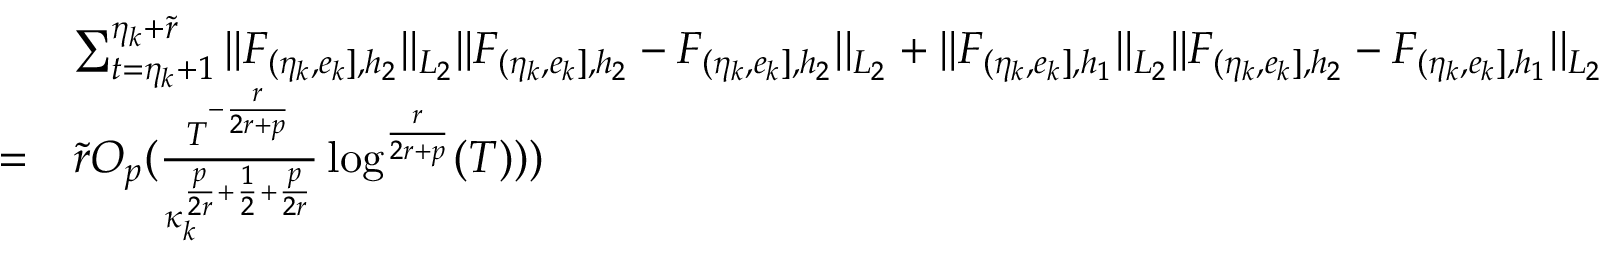Convert formula to latex. <formula><loc_0><loc_0><loc_500><loc_500>\begin{array} { r l } & { \sum _ { t = \eta _ { k } + 1 } ^ { \eta _ { k } + \widetilde { r } } | | F _ { ( \eta _ { k } , e _ { k } ] , { h _ { 2 } } } | | _ { L _ { 2 } } | | F _ { ( \eta _ { k } , e _ { k } ] , { h _ { 2 } } } - F _ { ( \eta _ { k } , e _ { k } ] , { h _ { 2 } } } | | _ { L _ { 2 } } + | | F _ { ( \eta _ { k } , e _ { k } ] , { h _ { 1 } } } | | _ { L _ { 2 } } | | F _ { ( \eta _ { k } , e _ { k } ] , { h _ { 2 } } } - F _ { ( \eta _ { k } , e _ { k } ] , { h _ { 1 } } } | | _ { L _ { 2 } } } \\ { = } & { \widetilde { r } O _ { p } ( \frac { T ^ { - \frac { r } { 2 r + p } } } { \kappa _ { k } ^ { \frac { p } { 2 r } + \frac { 1 } { 2 } + \frac { p } { 2 r } } } \log ^ { \frac { r } { 2 r + p } } ( T ) ) ) } \end{array}</formula> 